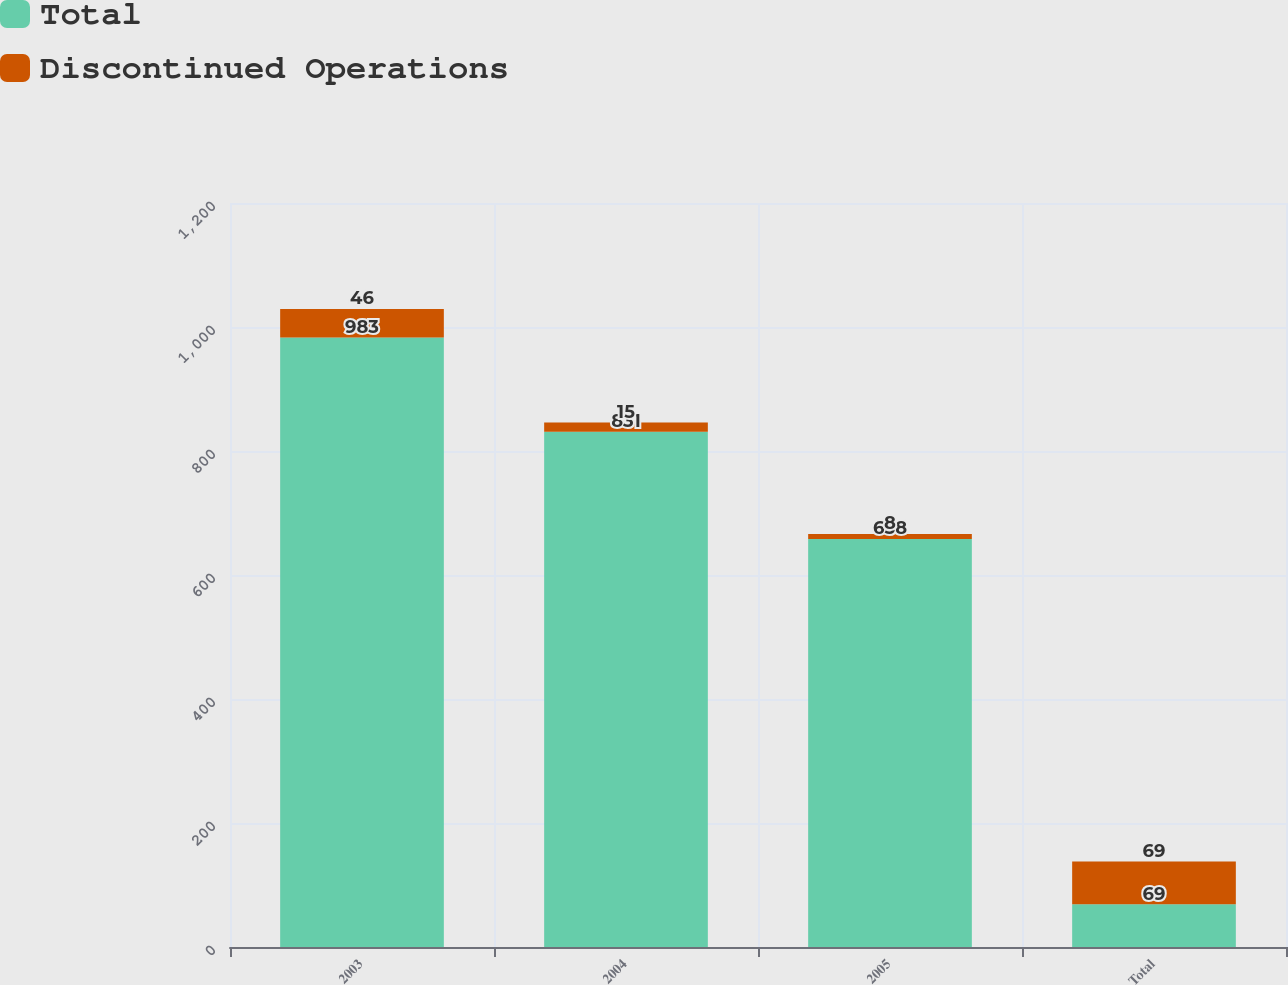Convert chart to OTSL. <chart><loc_0><loc_0><loc_500><loc_500><stacked_bar_chart><ecel><fcel>2003<fcel>2004<fcel>2005<fcel>Total<nl><fcel>Total<fcel>983<fcel>831<fcel>658<fcel>69<nl><fcel>Discontinued Operations<fcel>46<fcel>15<fcel>8<fcel>69<nl></chart> 